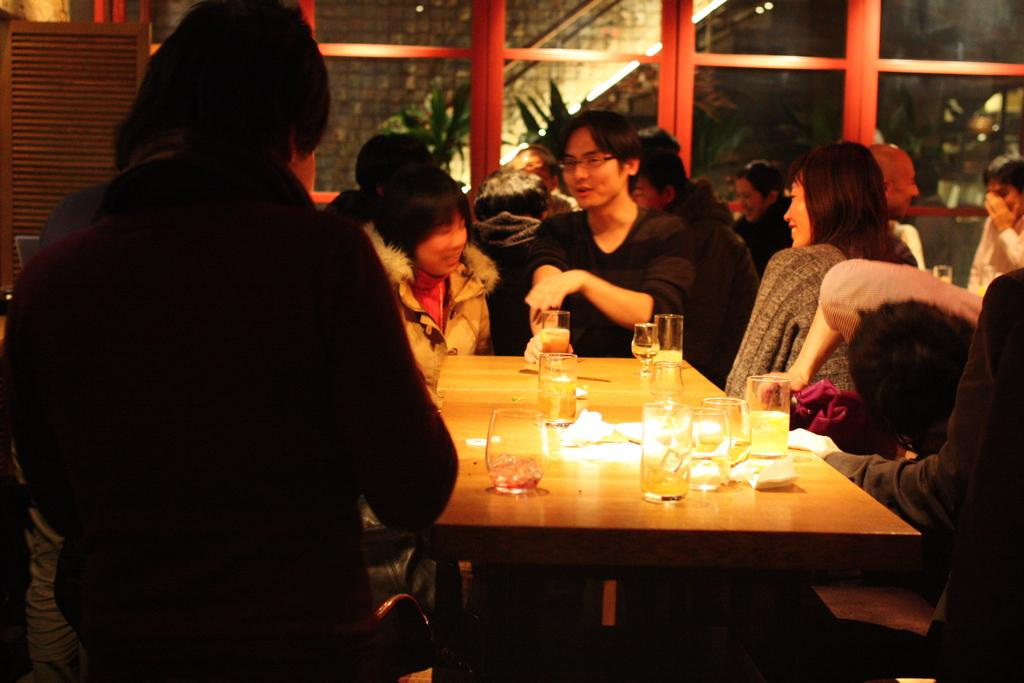What can be seen in the image involving multiple individuals? There is a group of people in the image. What objects are present on the table in the image? There are glasses and a tissue on the table in the image. What type of fiction is being read by the group of people in the image? There is no indication of any reading material or fiction in the image; it only shows a group of people and objects on a table. 